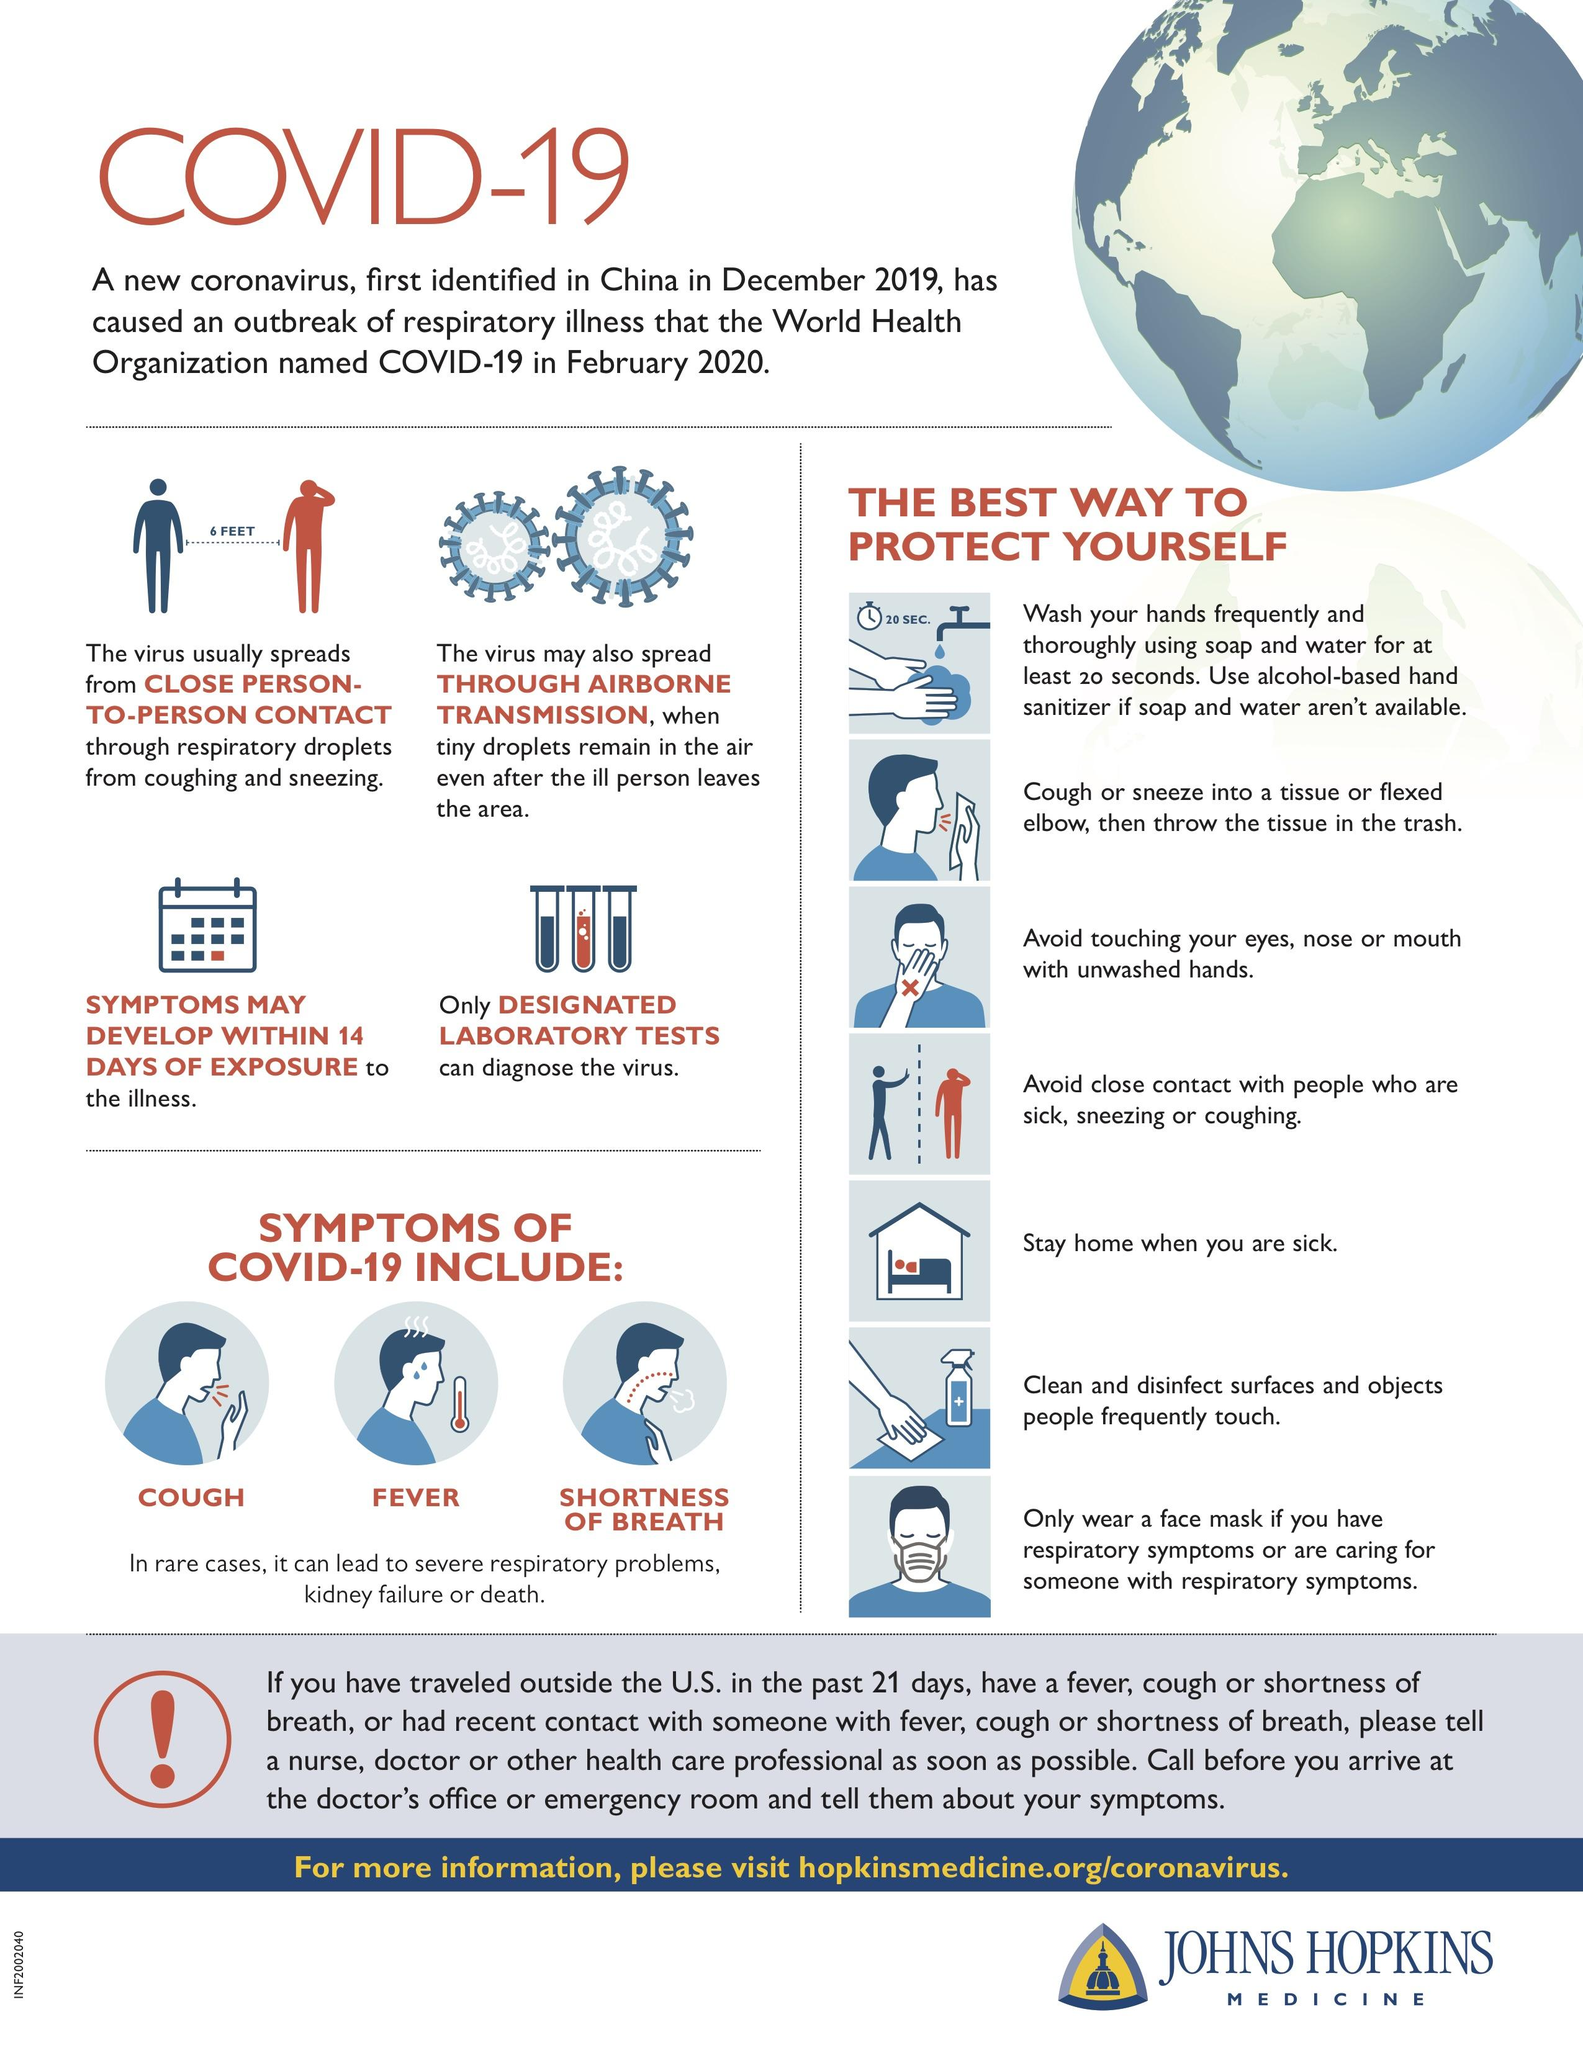Highlight a few significant elements in this photo. It is crucial for each individual to maintain a minimum safe distance of six feet to effectively prevent the spread of COVID-19 virus. COUGH, FEVER, SHORTNESS OF BREATH are common symptoms of COVID-19. The onset of symptoms for the coronavirus disease typically occurs within 14 days. 